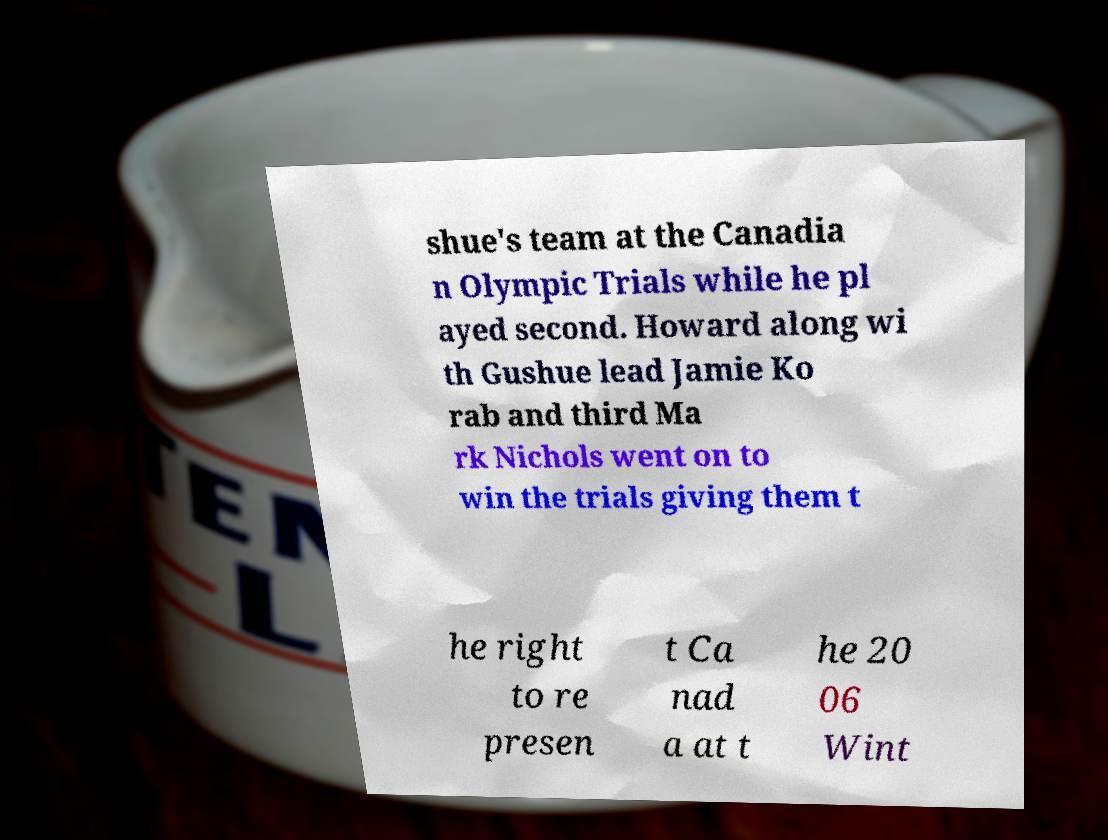I need the written content from this picture converted into text. Can you do that? shue's team at the Canadia n Olympic Trials while he pl ayed second. Howard along wi th Gushue lead Jamie Ko rab and third Ma rk Nichols went on to win the trials giving them t he right to re presen t Ca nad a at t he 20 06 Wint 